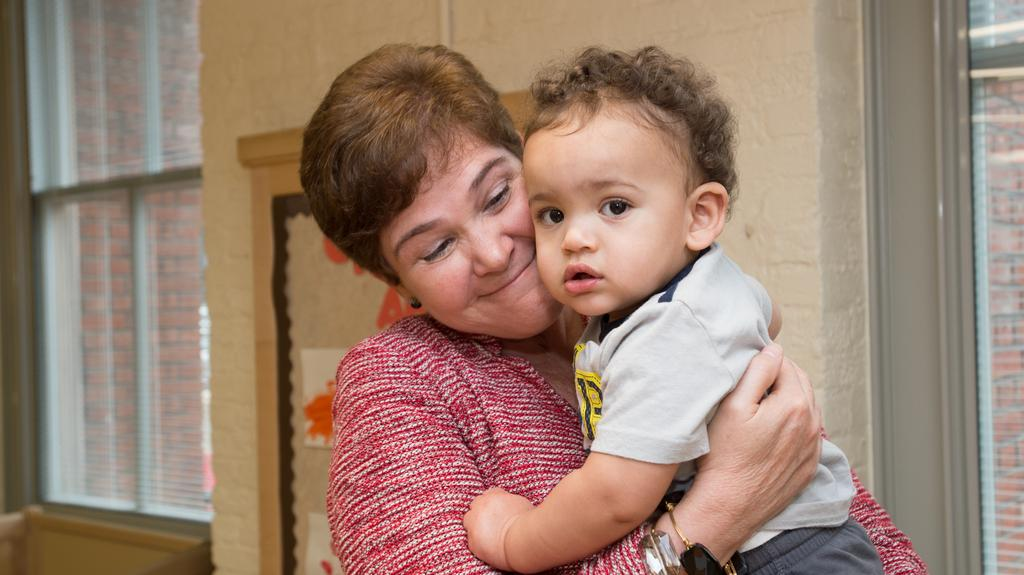Who is the main subject in the image? There is a woman in the image. What is the woman doing in the image? The woman is holding a baby in her arms. What is the woman's expression in the image? The woman is smiling. What can be seen in the background of the image? There is a wall, windows, and a frame on the wall in the background of the image. What type of meal is being prepared in the background of the image? There is no meal preparation visible in the image; it only shows a woman holding a baby and the background details mentioned earlier. 